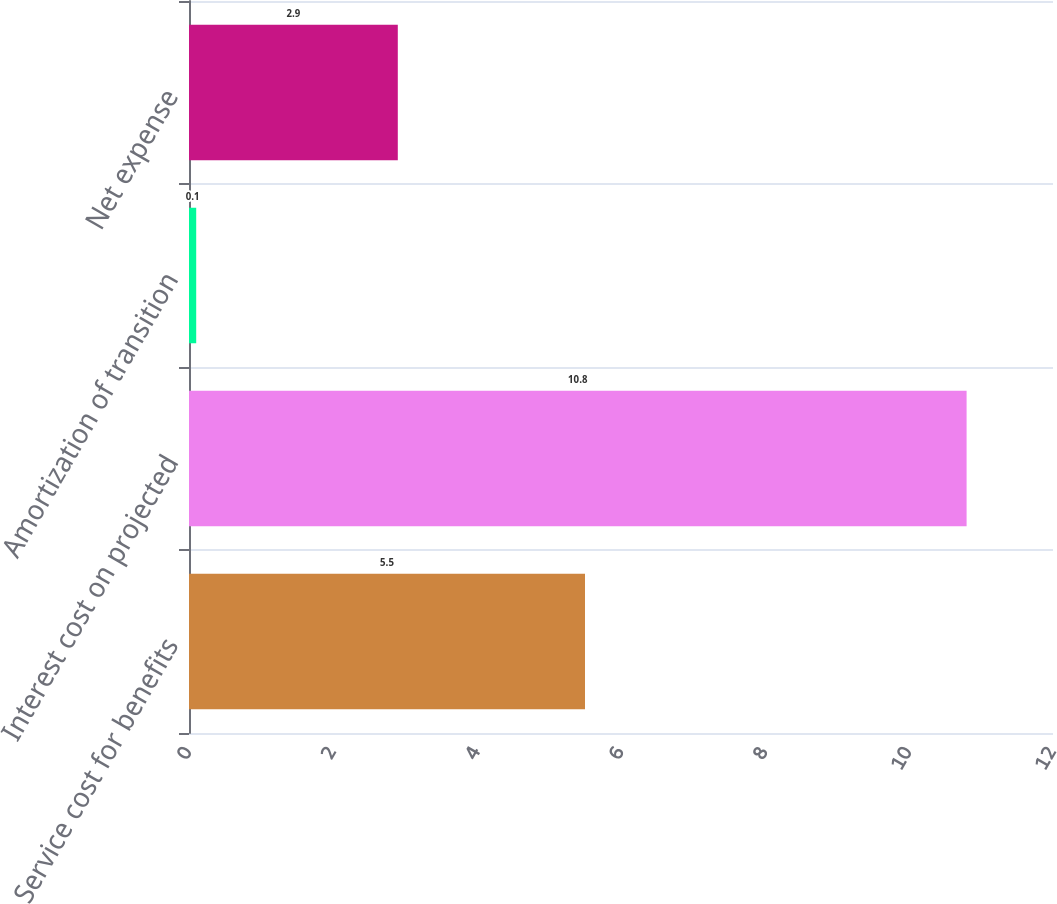Convert chart to OTSL. <chart><loc_0><loc_0><loc_500><loc_500><bar_chart><fcel>Service cost for benefits<fcel>Interest cost on projected<fcel>Amortization of transition<fcel>Net expense<nl><fcel>5.5<fcel>10.8<fcel>0.1<fcel>2.9<nl></chart> 